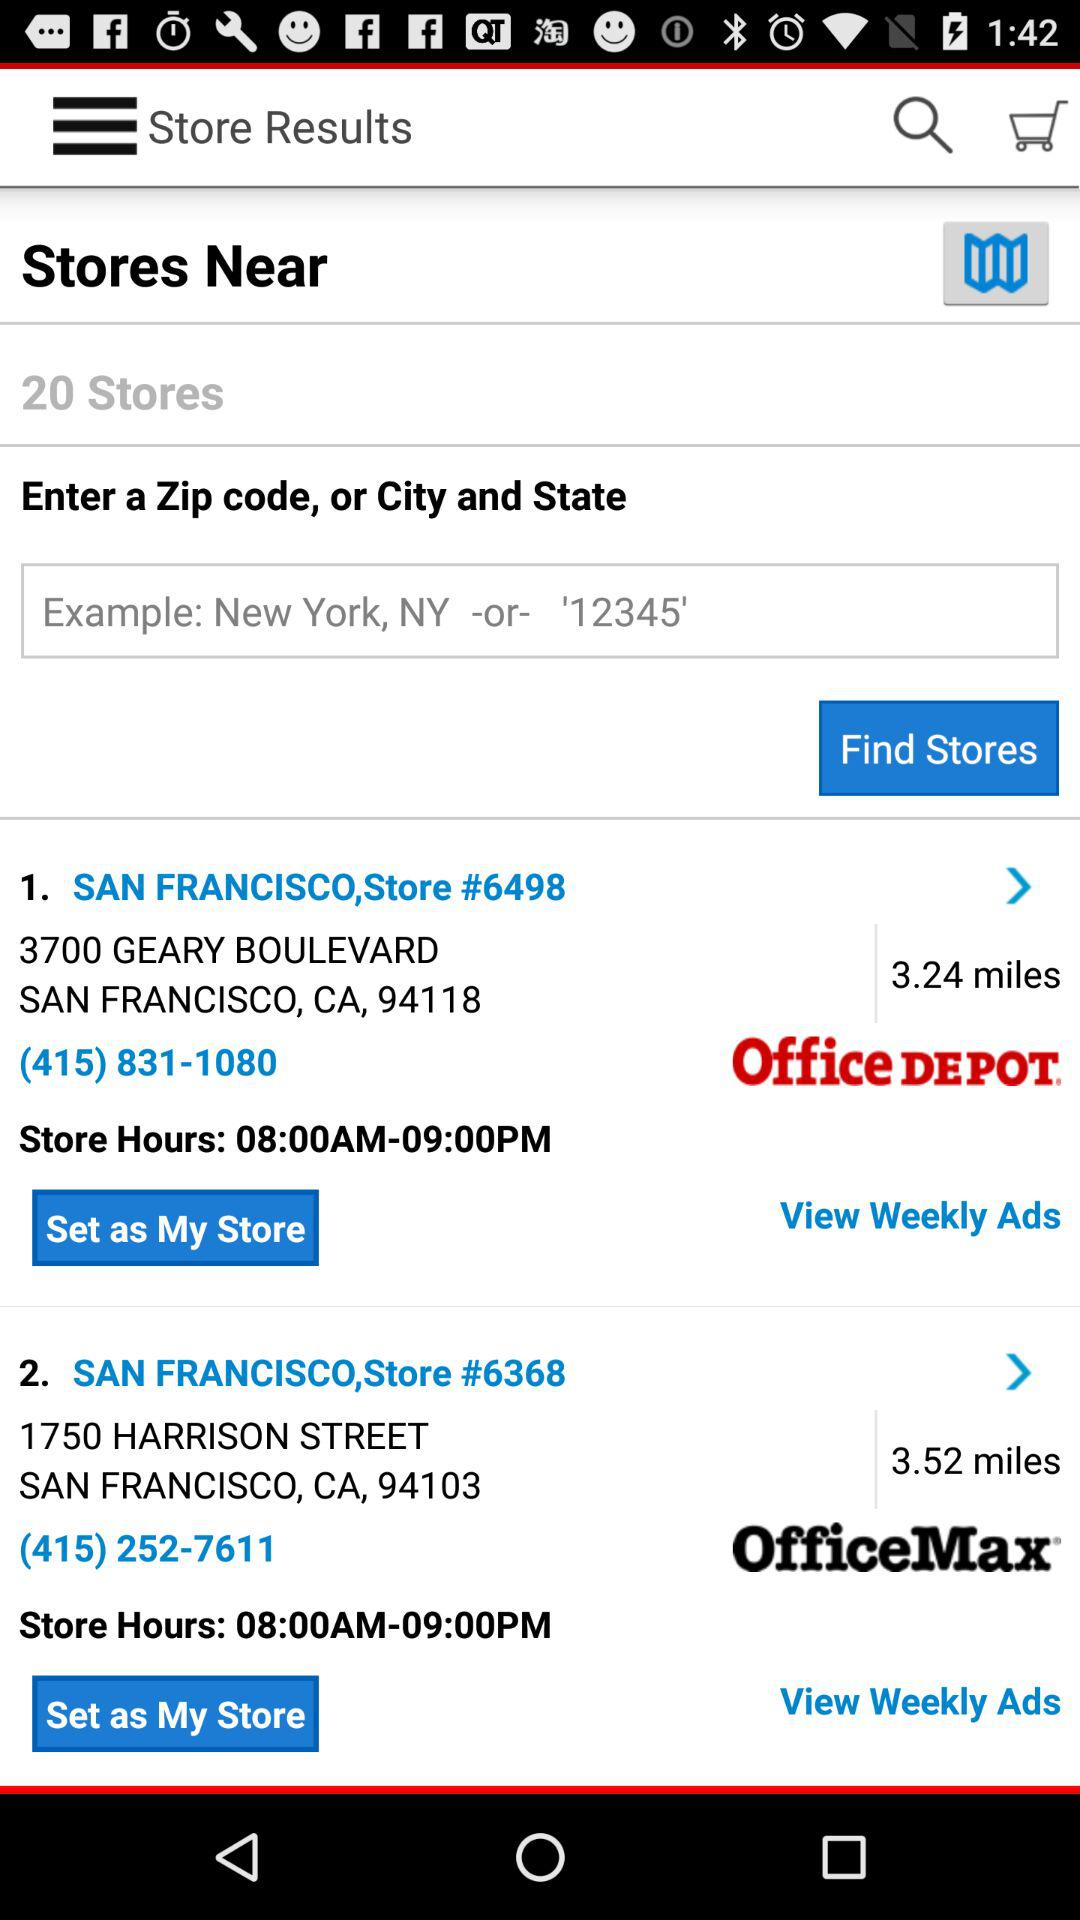What are the hours of San Francisco, Store #6498? The hours of San Francisco, Store #6498 are from 08:00 AM to 09:00 PM. 